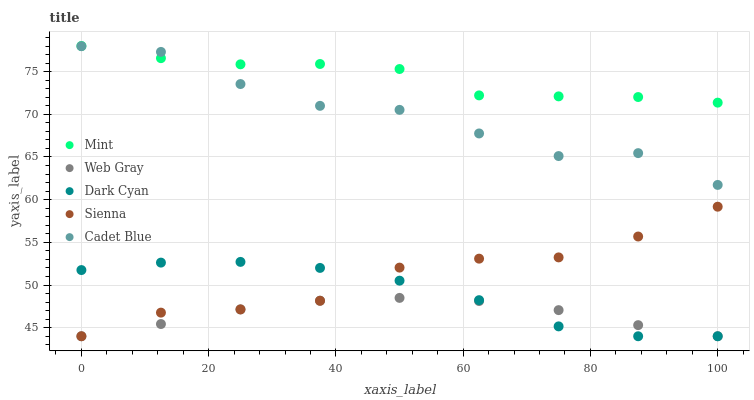Does Web Gray have the minimum area under the curve?
Answer yes or no. Yes. Does Mint have the maximum area under the curve?
Answer yes or no. Yes. Does Sienna have the minimum area under the curve?
Answer yes or no. No. Does Sienna have the maximum area under the curve?
Answer yes or no. No. Is Web Gray the smoothest?
Answer yes or no. Yes. Is Cadet Blue the roughest?
Answer yes or no. Yes. Is Sienna the smoothest?
Answer yes or no. No. Is Sienna the roughest?
Answer yes or no. No. Does Dark Cyan have the lowest value?
Answer yes or no. Yes. Does Mint have the lowest value?
Answer yes or no. No. Does Mint have the highest value?
Answer yes or no. Yes. Does Sienna have the highest value?
Answer yes or no. No. Is Sienna less than Cadet Blue?
Answer yes or no. Yes. Is Mint greater than Dark Cyan?
Answer yes or no. Yes. Does Dark Cyan intersect Sienna?
Answer yes or no. Yes. Is Dark Cyan less than Sienna?
Answer yes or no. No. Is Dark Cyan greater than Sienna?
Answer yes or no. No. Does Sienna intersect Cadet Blue?
Answer yes or no. No. 